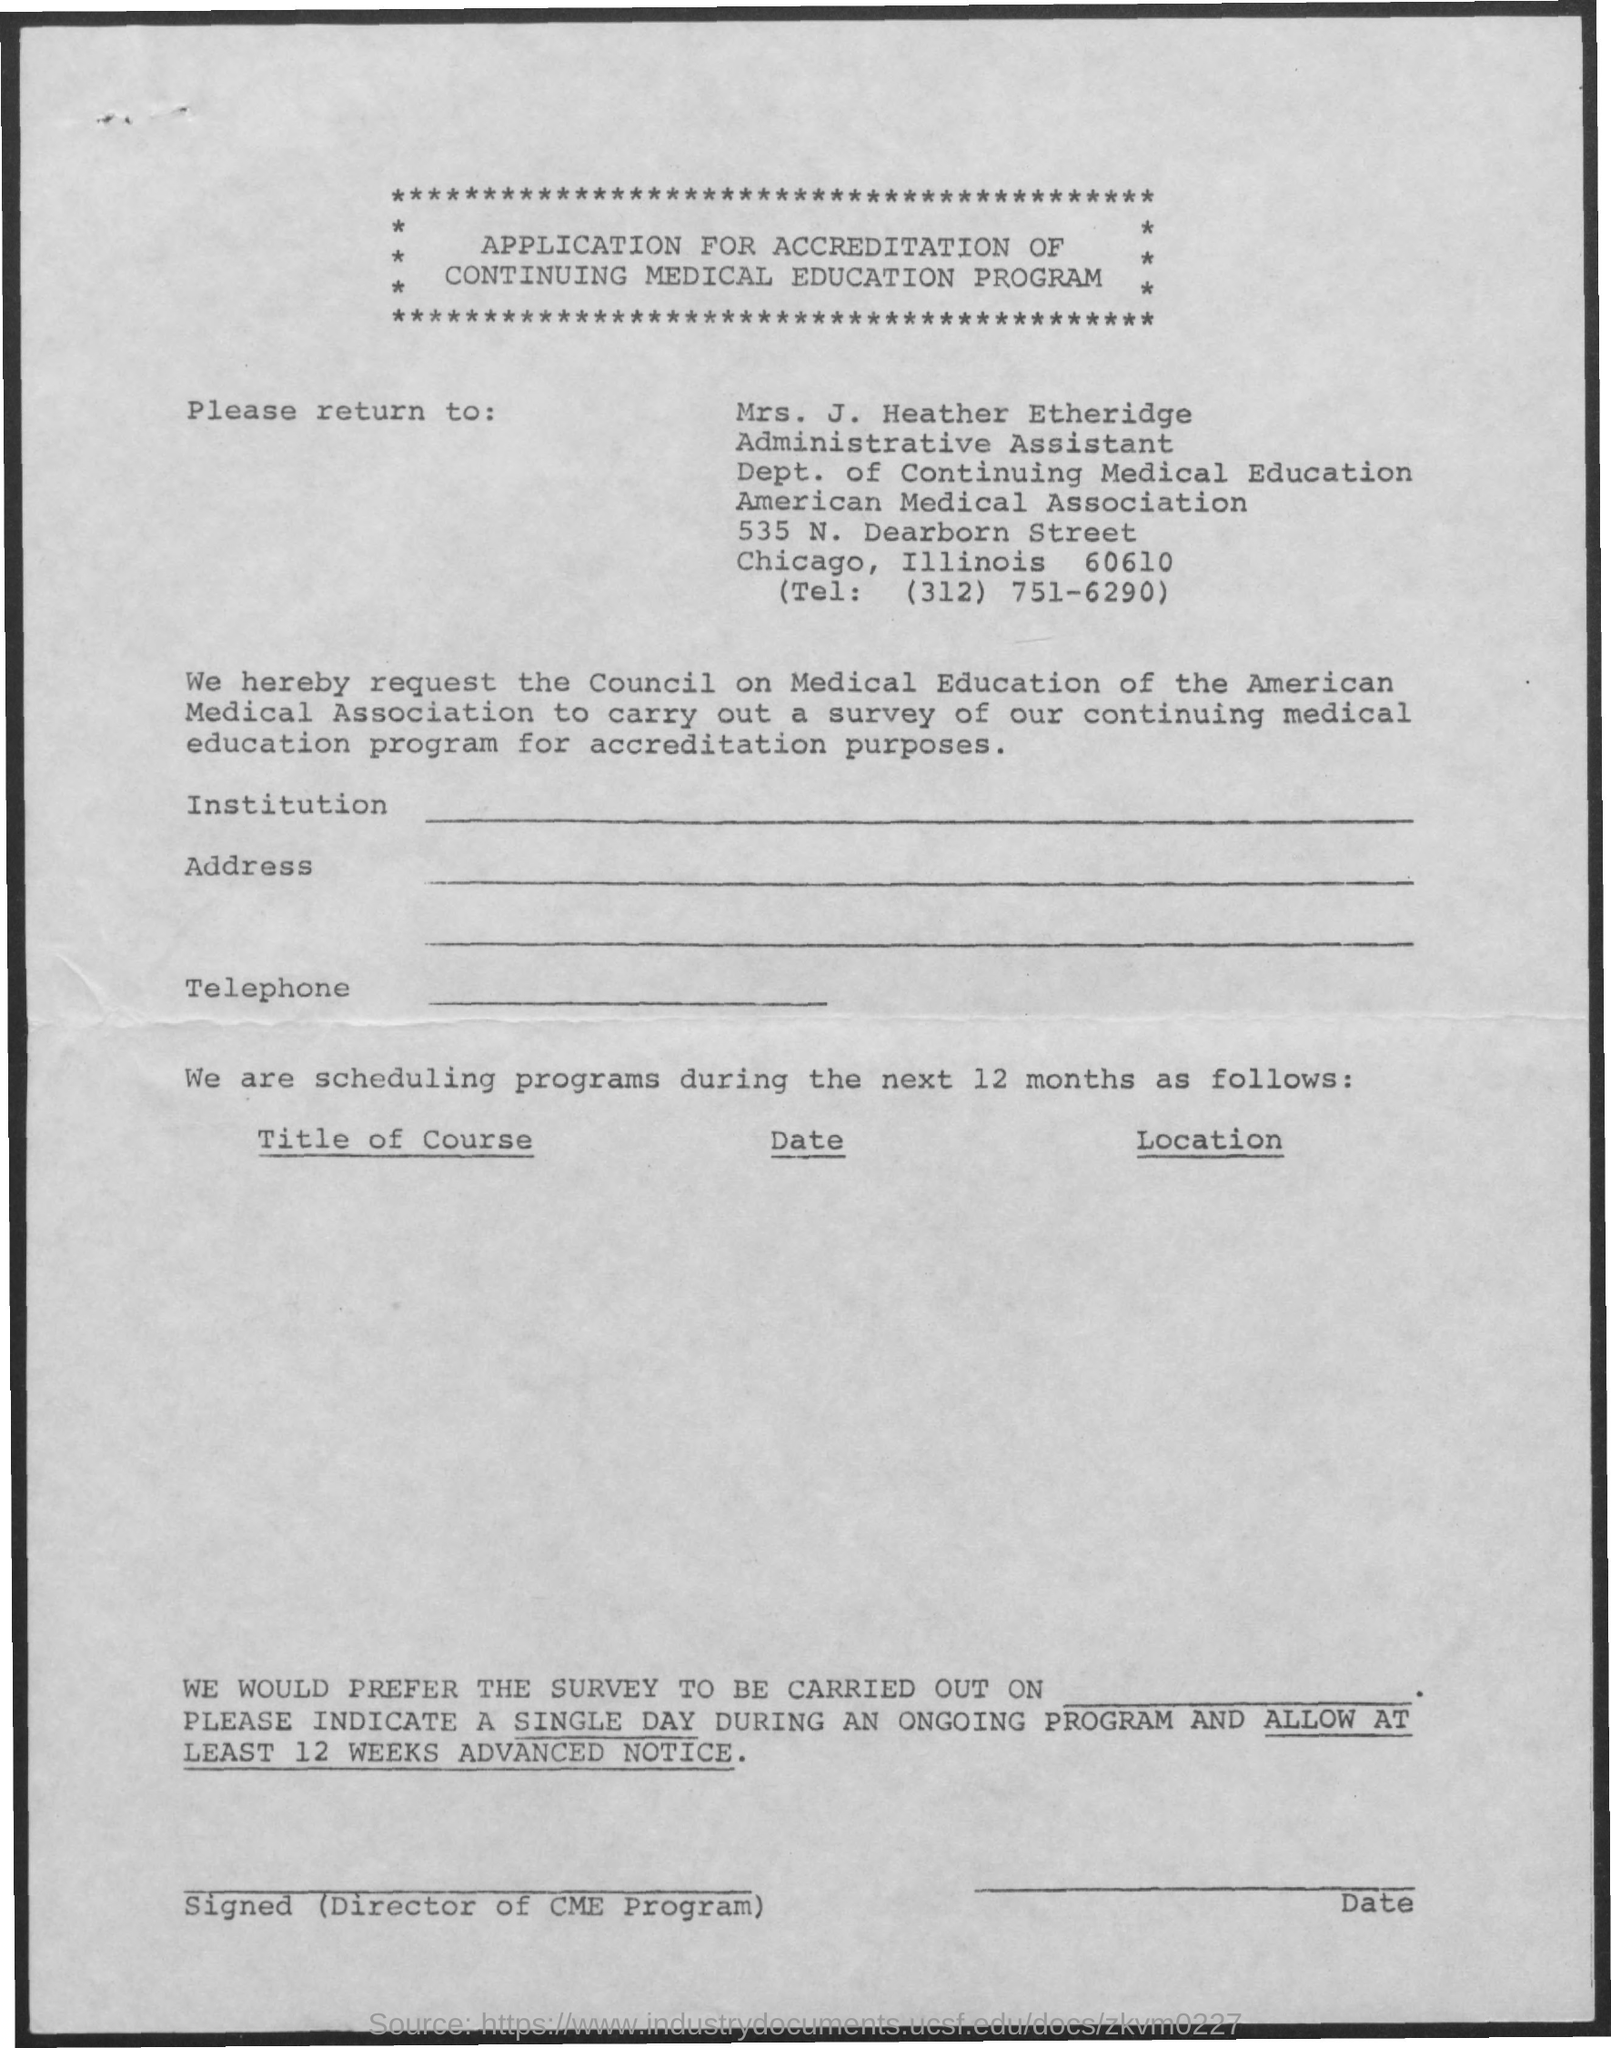What is the document about?
Keep it short and to the point. APPLICATION FOR ACCREDITATION OF CONTINUING MEDICAL EDUCATION PROGRAM. To whom should the form be returned?
Provide a short and direct response. Mrs. J. Heather Etheridge. What is the designation of Mrs. J. Heather Etheridge?
Provide a succinct answer. Administrative Assistant. What is the telephone number given in the form?
Provide a succinct answer. (312) 751-6290. 